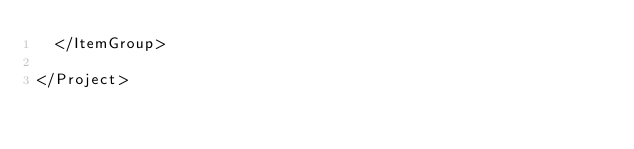<code> <loc_0><loc_0><loc_500><loc_500><_XML_>  </ItemGroup>

</Project>
</code> 